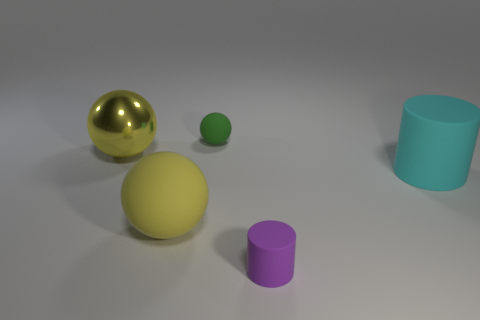Add 5 large yellow shiny objects. How many objects exist? 10 Subtract all big yellow balls. How many balls are left? 1 Subtract all cyan cylinders. How many cylinders are left? 1 Subtract all spheres. How many objects are left? 2 Subtract 1 spheres. How many spheres are left? 2 Subtract all cyan cylinders. How many yellow spheres are left? 2 Subtract all shiny balls. Subtract all balls. How many objects are left? 1 Add 5 big things. How many big things are left? 8 Add 1 large cyan things. How many large cyan things exist? 2 Subtract 0 red cylinders. How many objects are left? 5 